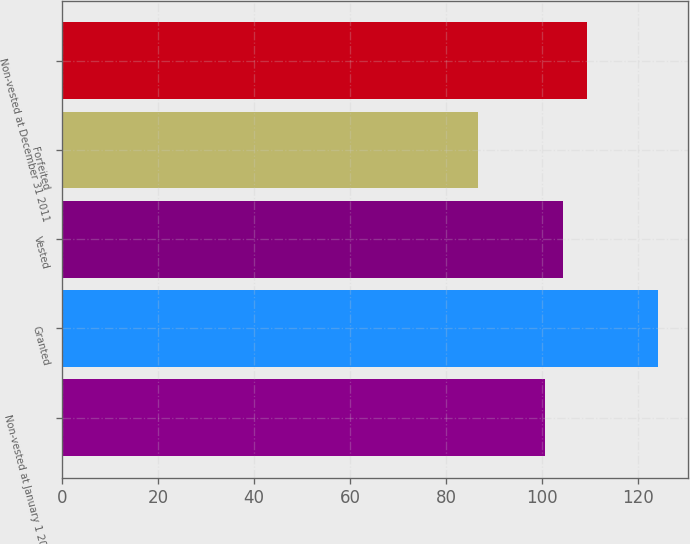Convert chart. <chart><loc_0><loc_0><loc_500><loc_500><bar_chart><fcel>Non-vested at January 1 2011<fcel>Granted<fcel>Vested<fcel>Forfeited<fcel>Non-vested at December 31 2011<nl><fcel>100.72<fcel>124.16<fcel>104.47<fcel>86.61<fcel>109.31<nl></chart> 